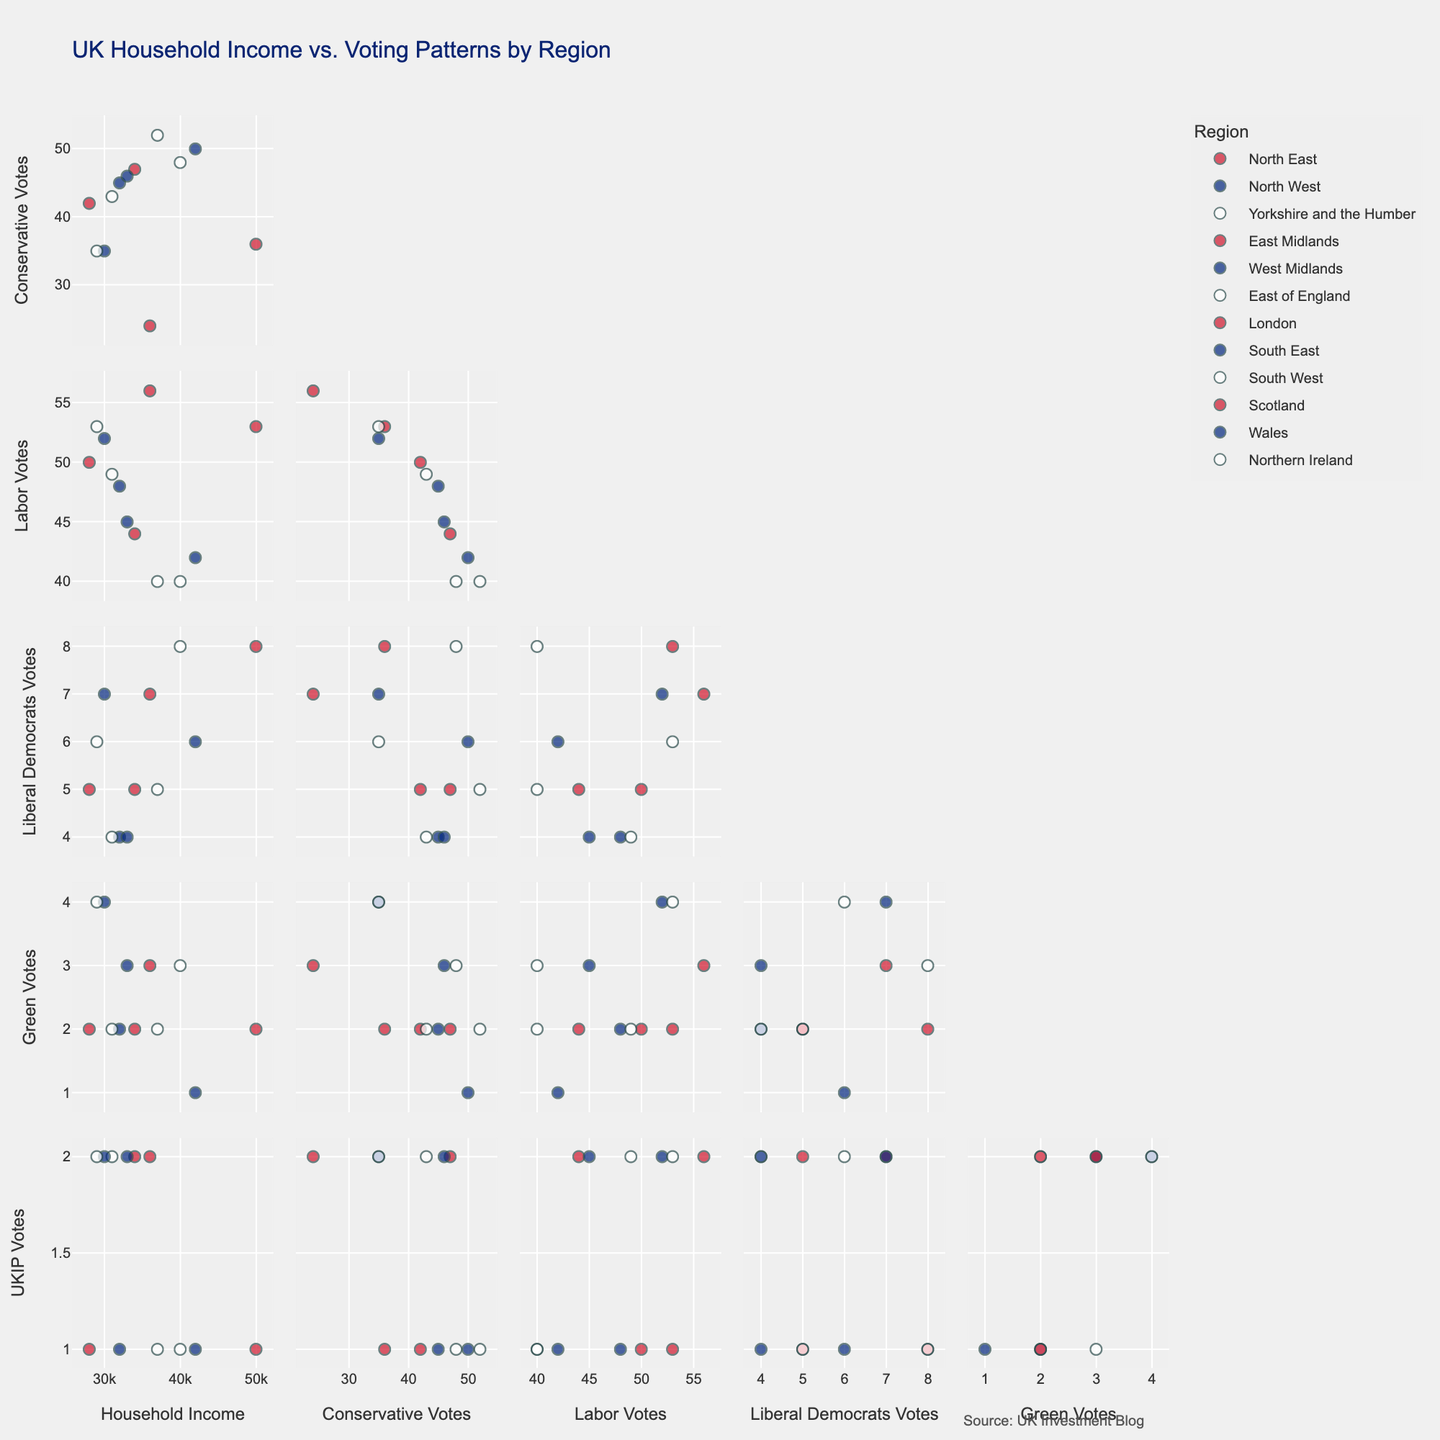What's the title of the figure? The title of the figure is typically placed at the top center of the plot. In this SPLOM, the title explicitly describes what the scatter matrix is about and includes details like the area of focus (UK Household Income vs. Voting Patterns) and the segmentation (by Region).
Answer: "UK Household Income vs. Voting Patterns by Region" How many regions are shown in the figure? Each scatter point in the SPLOM represents a region, and a unique color is used per region. By counting the number of different colors used for the points, we can determine the number of regions.
Answer: 12 Which region has the highest household income? To find the region with the highest household income, locate the plot for "Household Income" on the x-axis against any other variable on the y-axis. Then, identify the point at the far right of the plot because higher values are further to the right.
Answer: London In which region do Conservative votes and household income appear to be most positively correlated? Check the scatter plot where "Household Income" and "Conservative Votes" are plotted against each other. Look for a trend where points move from the bottom-left to the top-right, which indicates a positive correlation. Determine the region by the color coding if there is a clear trend.
Answer: East of England What is the approximate range of household income across all regions? Locate the plot that has "Household Income" on either the x or y-axis and determine the minimum and maximum points along that axis. This will give the range.
Answer: £28,000 - £50,000 Which region shows a high percentage of Green votes with a relatively lower household income? Find the plot with "Green Votes" versus "Household Income". Look for points that are higher up (higher Green votes) and towards the left (lower household income). Identify the region by the color of the points.
Answer: Wales Is there an evident relationship between Labor votes and household income? Examine the scatter plot comparing "Household Income" and "Labor Votes". Look for any visible trend (positive, negative, or no correlation). Notice how points are distributed—whether they follow a pattern or are scattered randomly.
Answer: Yes, generally negative What's the combined percentage of Liberal Democrat votes in the South regions? Identify the regions considered South (South East, South West). Look at the data points for these regions in the "Liberal Democrats Votes" plot. Sum their percentages.
Answer: 14% Which region shows the highest UKIP votes, and is this region's household income above or below average? Locate the plot comparing "Household Income" with "UKIP Votes". Identify the point at the very top (highest UKIP votes). Check the household income for this point and compare it to the average household income from the data.
Answer: Yorkshire and the Humber, below average Are there any regions with a significant negative correlation between household income and Conservative votes? Look at the plot with "Household Income" versus "Conservative Votes". Identify any regions where the points trend from the top-left to bottom-right. Determine which region(s) show this behavior by the color coding.
Answer: Scotland 